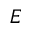<formula> <loc_0><loc_0><loc_500><loc_500>E</formula> 